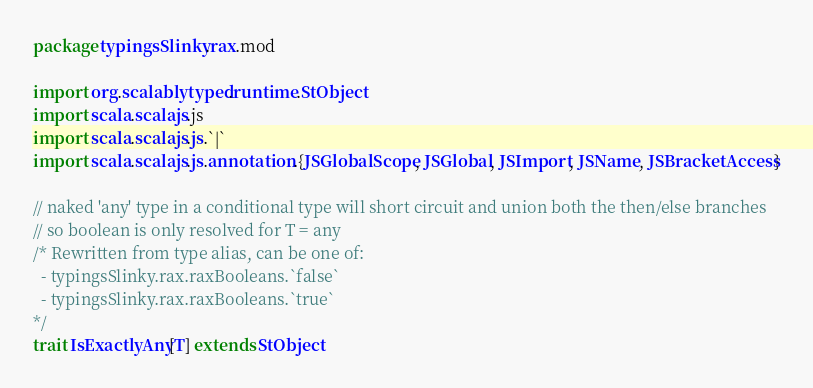Convert code to text. <code><loc_0><loc_0><loc_500><loc_500><_Scala_>package typingsSlinky.rax.mod

import org.scalablytyped.runtime.StObject
import scala.scalajs.js
import scala.scalajs.js.`|`
import scala.scalajs.js.annotation.{JSGlobalScope, JSGlobal, JSImport, JSName, JSBracketAccess}

// naked 'any' type in a conditional type will short circuit and union both the then/else branches
// so boolean is only resolved for T = any
/* Rewritten from type alias, can be one of: 
  - typingsSlinky.rax.raxBooleans.`false`
  - typingsSlinky.rax.raxBooleans.`true`
*/
trait IsExactlyAny[T] extends StObject
</code> 